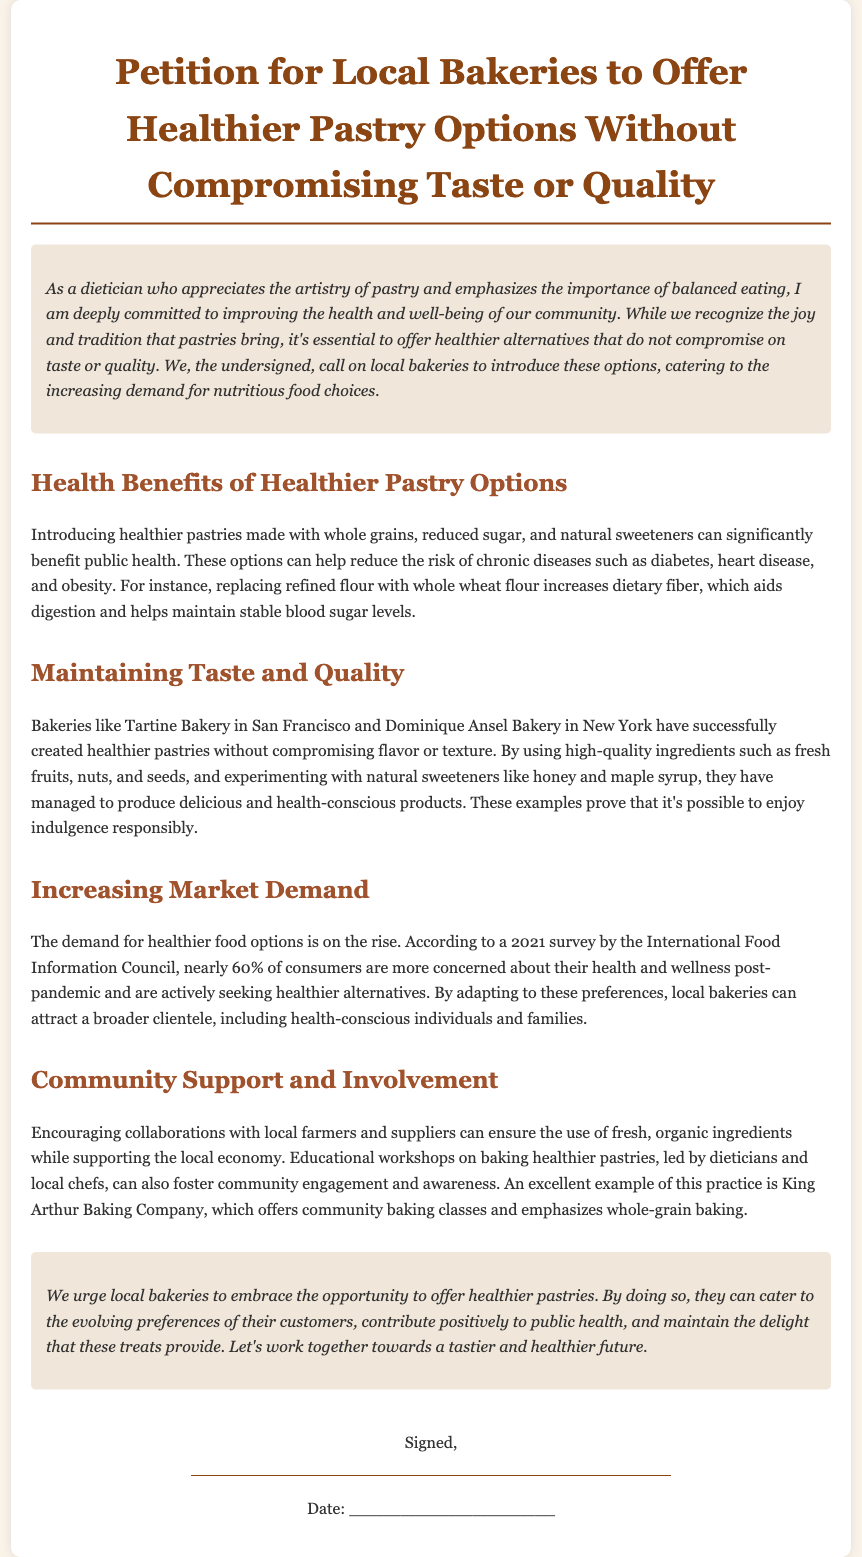What is the title of the petition? The title of the petition is stated prominently at the top of the document.
Answer: Petition for Local Bakeries to Offer Healthier Pastry Options Without Compromising Taste or Quality What is one health benefit mentioned in the petition? The document outlines health benefits related to healthier pastries, specifically noting reduced risk of chronic diseases.
Answer: Reduce risk of chronic diseases Which bakery is mentioned as a successful example of healthier pastries? The petition lists bakeries known for their healthier pastry offerings, specifically naming one as an exemplar.
Answer: Tartine Bakery What proportion of consumers is seeking healthier alternatives according to the 2021 survey? The document refers to a specific percentage from a survey regarding consumer trends post-pandemic.
Answer: Nearly 60% What type of ingredient does the petition suggest should be used in healthier pastries? The text advocates for specific high-quality ingredients in healthier pastries.
Answer: Whole grains What does the petition urge local bakeries to embrace? The call to action emphasizes a particular opportunity for bakeries in the community.
Answer: Healthier pastries What is one suggested community activity to support healthier pastries? The petition proposes educational engagements to foster community involvement.
Answer: Workshops on baking healthier pastries Who is the author of the petition? The identity of the person advocating for the petition is mentioned in the introduction.
Answer: A dietician 